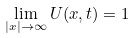<formula> <loc_0><loc_0><loc_500><loc_500>\lim _ { | { x } | \rightarrow \infty } U ( { x } , t ) = 1</formula> 